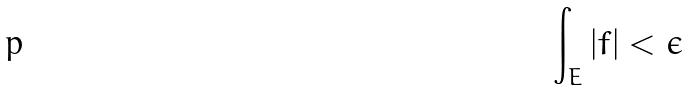<formula> <loc_0><loc_0><loc_500><loc_500>\int _ { E } | f | < \epsilon</formula> 